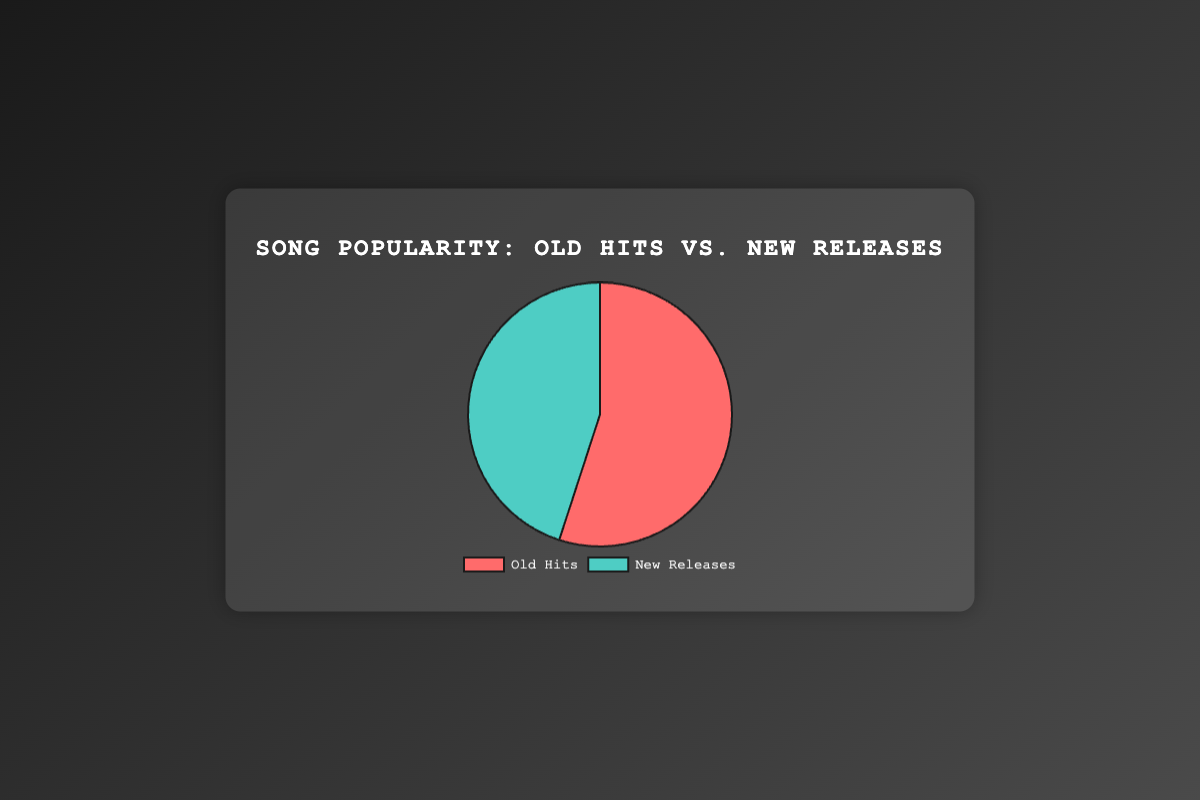What is the percentage of Old Hits in the pie chart? The pie chart shows the percentage of song popularity between Old Hits and New Releases. The section for Old Hits indicates a 55% share.
Answer: 55% Which category has a lower percentage in the pie chart? Comparing the two categories, Old Hits and New Releases, New Releases have a lower percentage at 45% compared to Old Hits at 55%.
Answer: New Releases How much greater is the popularity percentage of Old Hits compared to New Releases? The popularity of Old Hits is 55% and New Releases is 45%. The difference can be calculated as 55% - 45% = 10%.
Answer: 10% What is the combined percentage for both categories? The pie chart shows 55% for Old Hits and 45% for New Releases. Summing these percentages, 55% + 45% = 100%.
Answer: 100% If we were to allocate the total song popularity equally, how much would each category get? With a total of 100%, equally dividing it by two categories gives 100% / 2 = 50% for each category.
Answer: 50% Which category has more popularity, and by how much? Old Hits has a higher popularity percentage at 55% compared to New Releases at 45%. The difference between them is 55% - 45% = 10%.
Answer: Old Hits, by 10% What color represents New Releases in the pie chart? Observing the pie chart, the section labeled as New Releases is represented by the color green.
Answer: Green If we were to visually convert the percentage of Old Hits into degrees for a pie chart, what would it be? A circle is 360 degrees, and Old Hits make up 55% of it. Therefore, converting 55% to degrees: (55/100) * 360 = 198 degrees.
Answer: 198 degrees How would the visual size of the New Releases segment compare if its percentage increased to 50%? Currently, New Releases constitute 45%. If it increases to 50%, its section in the pie chart would visually become larger by 5%, covering half the pie chart.
Answer: Larger by 5% What are the color representations for both categories in the pie chart? In the pie chart, Old Hits are represented by red, and New Releases are represented by green.
Answer: Old Hits: Red, New Releases: Green 